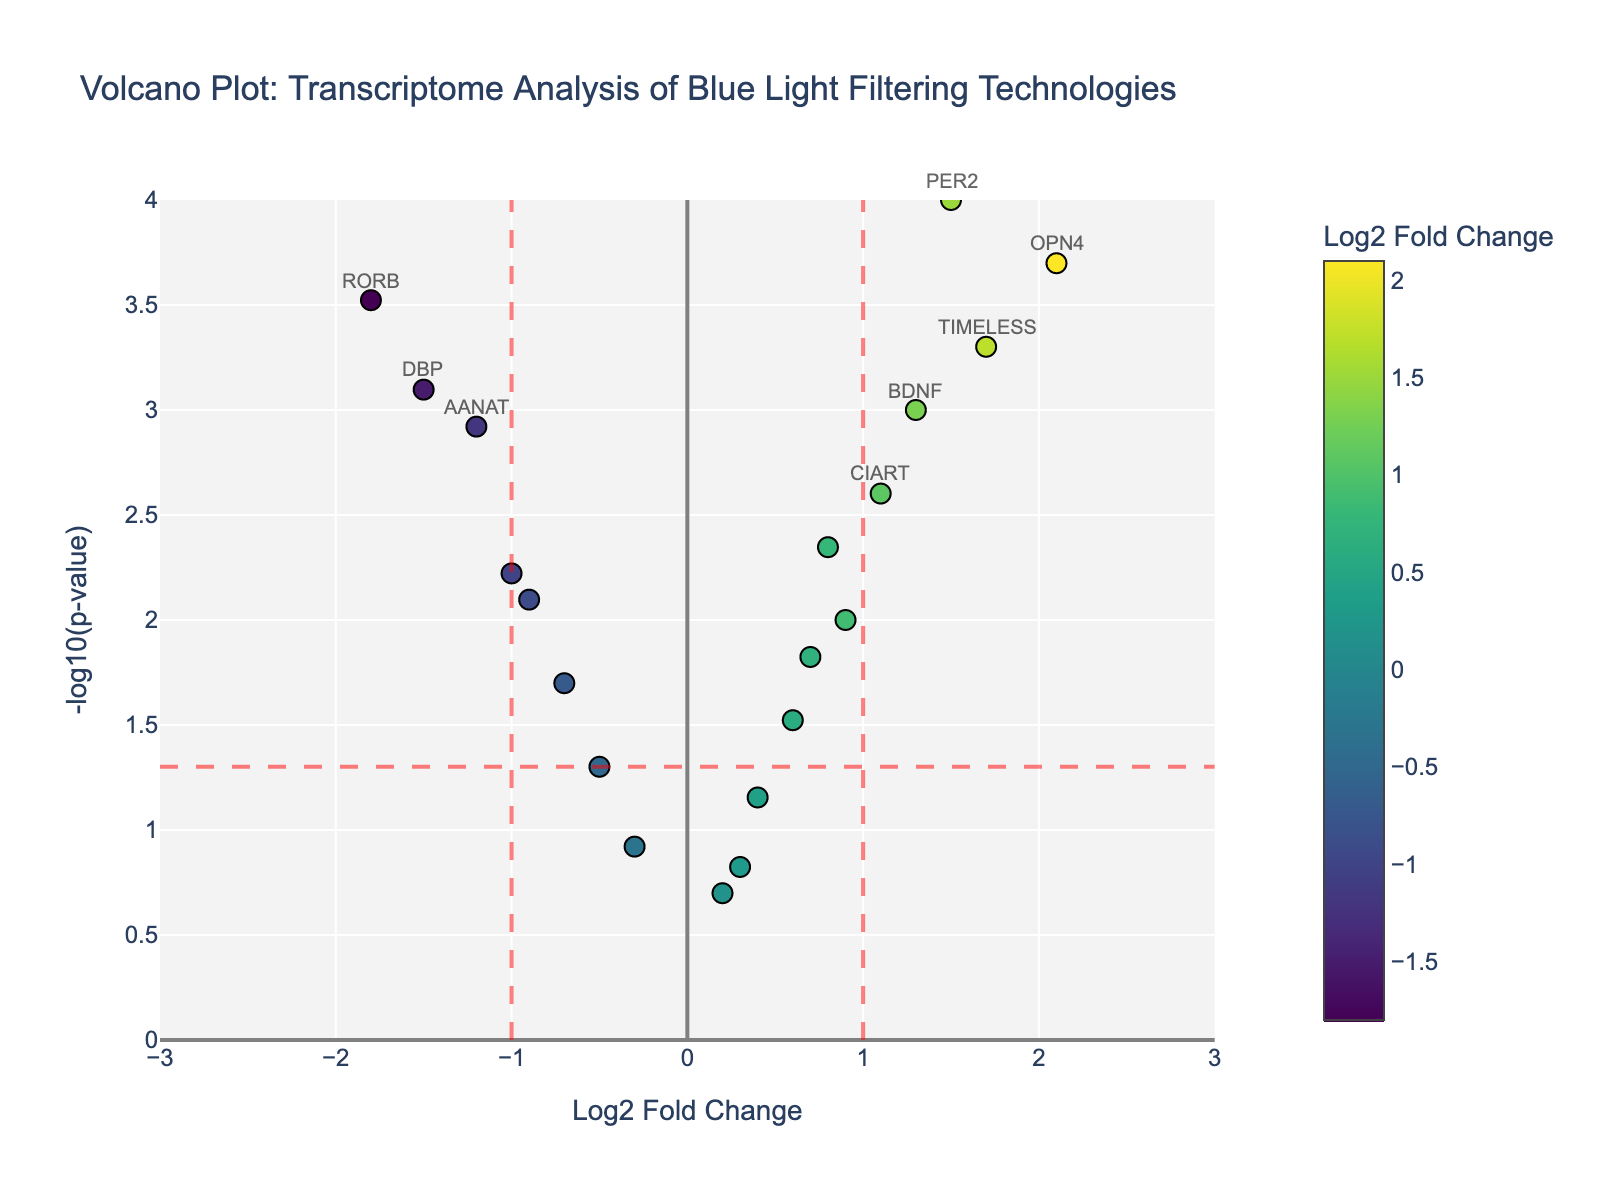How many genes are labeled in the plot? There are 20 data points in the plot. However, only significant genes (those with log2 fold change greater than 1 or less than -1 and p-value < 0.05) are labeled. Looking at the volcano plot, genes like AANAT, CRY1, etc., are labeled. By counting these labels, the total number of labeled genes is eight.
Answer: 8 What is the full title of the plot? The full title is displayed at the top of the volcano plot, reading "Volcano Plot: Transcriptome Analysis of Blue Light Filtering Technologies".
Answer: Volcano Plot: Transcriptome Analysis of Blue Light Filtering Technologies Which gene has the highest -log10(p-value)? The highest -log10(p-value) corresponds to the smallest p-value. From the plot, the gene with the smallest p-value is PER2, which translates to the highest -log10(p-value).
Answer: PER2 Is there any gene with a log2 fold change less than -1 and high significance (low p-value)? If so, name it. On the plot, significant genes with log2 fold change <-1 and p-value < 0.05 will be in the lower left quadrant and labeled. The gene RORB fits this criterion.
Answer: RORB What color scale is used to represent the log2 fold change in the plot? Observing the color variation of the dots, the colors follow a gradient from a dark shade of one color through a spectrum to another. This is characteristic of the Viridis color scale, a common color spectrum used for such data visualization.
Answer: Viridis Compare the significance of the genes OPN4 and CLOCK. Which one is more significant? The significance can be compared using the -log10(p-value) displayed on the y-axis. OPN4 is higher on the y-axis compared to CLOCK, indicating a higher -log10(p-value) and therefore higher significance.
Answer: OPN4 Which quadrant contains the gene CIART? The locations in a volcano plot are determined by the log2 fold change (x-axis) and -log10(p-value) (y-axis). CIART has a positive log2 fold change and high significance (low p-value), placing it in the upper right quadrant.
Answer: Upper right How many genes fall within the range of -1 < log2 fold change < 1 and p-value >= 0.05? Genes within this range are not labeled and fall in the central region with low significance. By examining the plot, it's clear genes like CLOCK, CSNK1E, GRIN2A, NPAS2, and CSNK1D meet these criteria. Summing them up, we get five.
Answer: 5 What are the x-axis and y-axis titles of the plot? The x-axis title, found below the x-axis, is "Log2 Fold Change" and the y-axis title, found to the left of the y-axis, is "-log10(p-value)".
Answer: Log2 Fold Change; -log10(p-value) Is there a gene with both low log2 fold change and high p-value? If so, which one? On the volcano plot, genes with low log2 fold change (close to 0) and high p-value (closer to the x-axis) are in the middle at the bottom. The gene NPAS2 fits this description.
Answer: NPAS2 